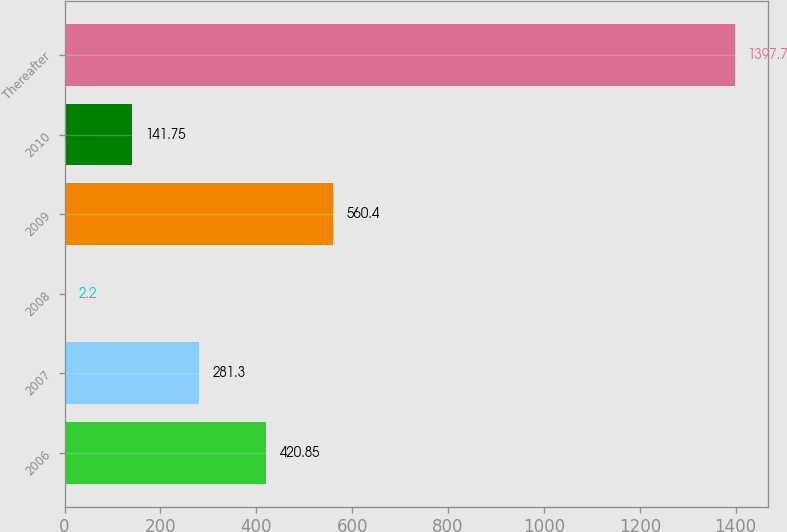Convert chart. <chart><loc_0><loc_0><loc_500><loc_500><bar_chart><fcel>2006<fcel>2007<fcel>2008<fcel>2009<fcel>2010<fcel>Thereafter<nl><fcel>420.85<fcel>281.3<fcel>2.2<fcel>560.4<fcel>141.75<fcel>1397.7<nl></chart> 